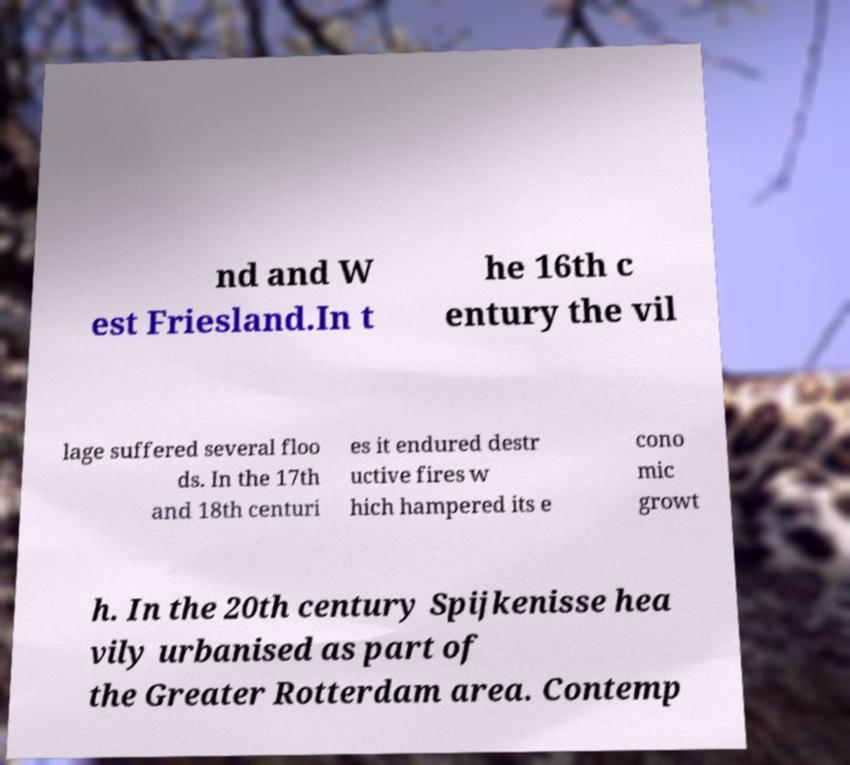Can you accurately transcribe the text from the provided image for me? nd and W est Friesland.In t he 16th c entury the vil lage suffered several floo ds. In the 17th and 18th centuri es it endured destr uctive fires w hich hampered its e cono mic growt h. In the 20th century Spijkenisse hea vily urbanised as part of the Greater Rotterdam area. Contemp 